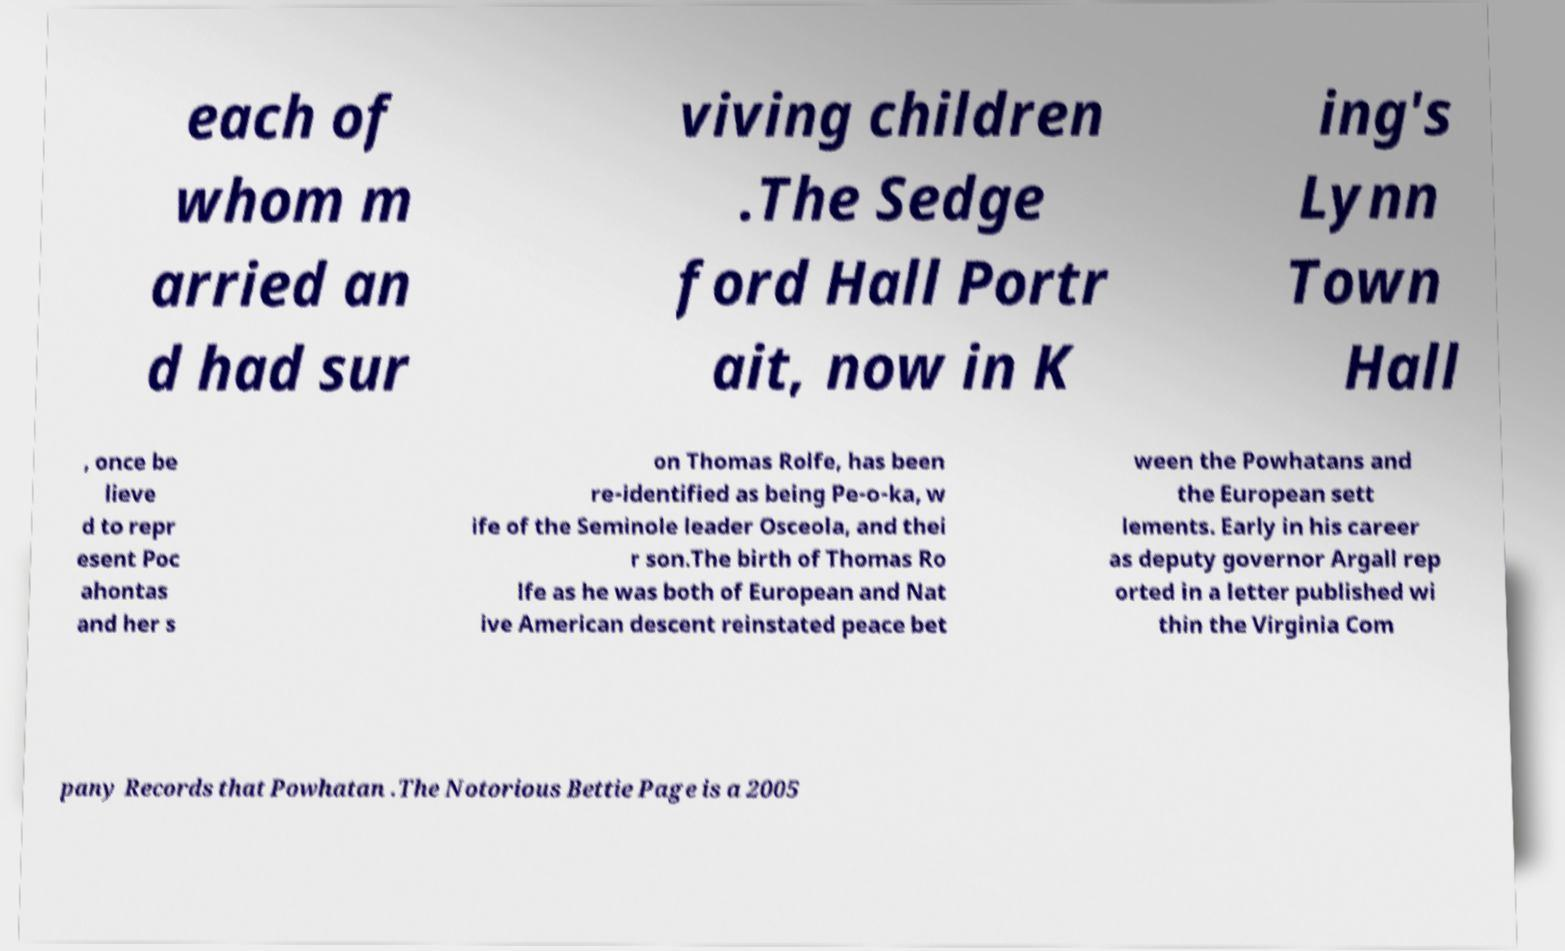What messages or text are displayed in this image? I need them in a readable, typed format. each of whom m arried an d had sur viving children .The Sedge ford Hall Portr ait, now in K ing's Lynn Town Hall , once be lieve d to repr esent Poc ahontas and her s on Thomas Rolfe, has been re-identified as being Pe-o-ka, w ife of the Seminole leader Osceola, and thei r son.The birth of Thomas Ro lfe as he was both of European and Nat ive American descent reinstated peace bet ween the Powhatans and the European sett lements. Early in his career as deputy governor Argall rep orted in a letter published wi thin the Virginia Com pany Records that Powhatan .The Notorious Bettie Page is a 2005 